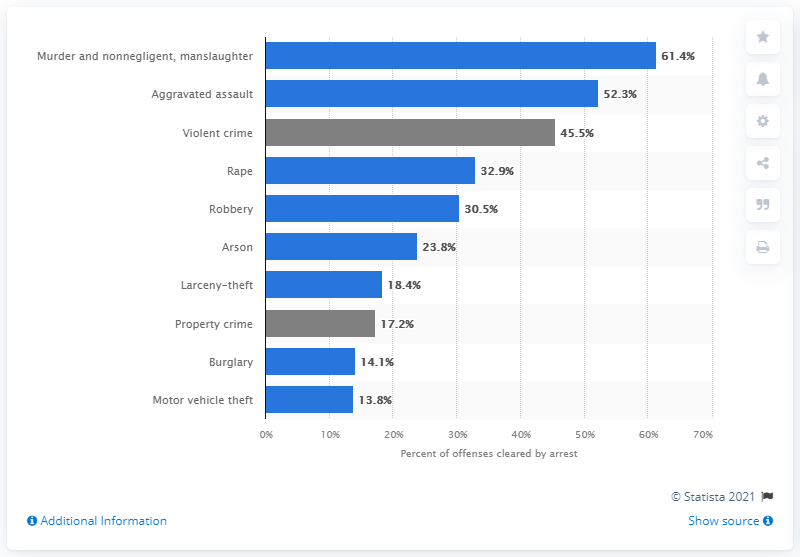Indicate a few pertinent items in this graphic. In 2019, the crime clearance rate was 13.8%, which was the lowest level in that year. 